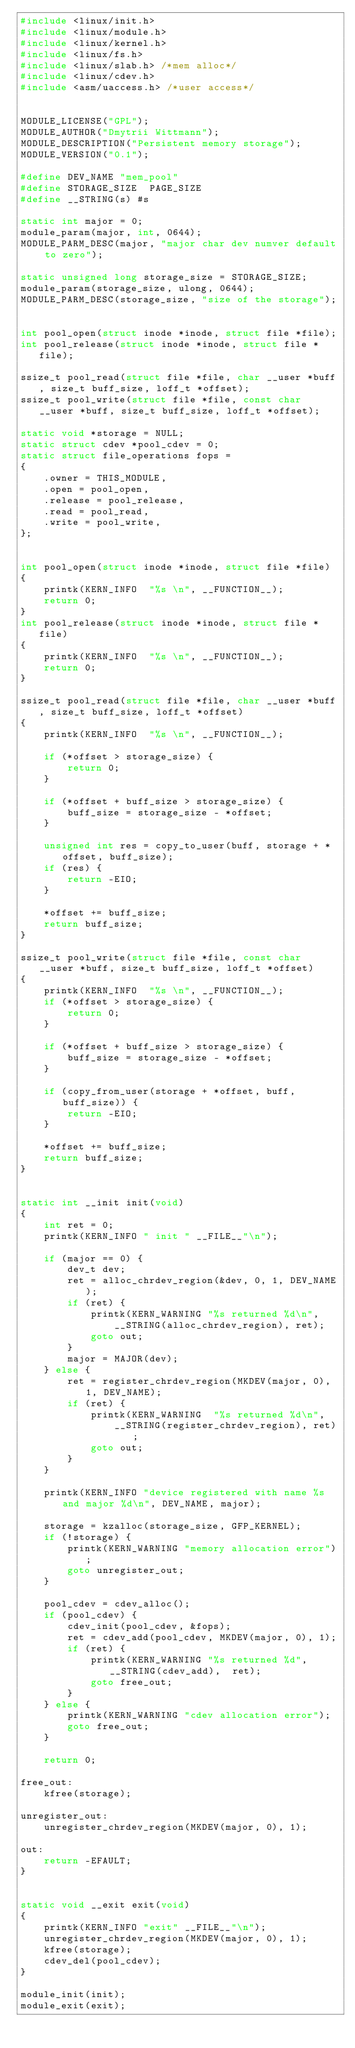<code> <loc_0><loc_0><loc_500><loc_500><_C_>#include <linux/init.h>
#include <linux/module.h>
#include <linux/kernel.h>
#include <linux/fs.h>
#include <linux/slab.h> /*mem alloc*/
#include <linux/cdev.h>
#include <asm/uaccess.h> /*user access*/ 

 
MODULE_LICENSE("GPL");
MODULE_AUTHOR("Dmytrii Wittmann");
MODULE_DESCRIPTION("Persistent memory storage");
MODULE_VERSION("0.1");

#define DEV_NAME "mem_pool"
#define STORAGE_SIZE  PAGE_SIZE
#define __STRING(s) #s

static int major = 0;
module_param(major, int, 0644);
MODULE_PARM_DESC(major, "major char dev numver default to zero");

static unsigned long storage_size = STORAGE_SIZE;
module_param(storage_size, ulong, 0644);
MODULE_PARM_DESC(storage_size, "size of the storage");


int pool_open(struct inode *inode, struct file *file);
int pool_release(struct inode *inode, struct file *file);

ssize_t pool_read(struct file *file, char __user *buff, size_t buff_size, loff_t *offset);
ssize_t pool_write(struct file *file, const char __user *buff, size_t buff_size, loff_t *offset);

static void *storage = NULL;
static struct cdev *pool_cdev = 0;
static struct file_operations fops = 
{
	.owner = THIS_MODULE,
	.open = pool_open,
	.release = pool_release,
	.read = pool_read,
	.write = pool_write,
};


int pool_open(struct inode *inode, struct file *file)
{
	printk(KERN_INFO  "%s \n", __FUNCTION__);
	return 0;
}
int pool_release(struct inode *inode, struct file *file)
{
	printk(KERN_INFO  "%s \n", __FUNCTION__);
	return 0;
}

ssize_t pool_read(struct file *file, char __user *buff, size_t buff_size, loff_t *offset)
{
	printk(KERN_INFO  "%s \n", __FUNCTION__);

	if (*offset > storage_size) {
		return 0;
	}

	if (*offset + buff_size > storage_size) {
		buff_size = storage_size - *offset;
	}

	unsigned int res = copy_to_user(buff, storage + *offset, buff_size);
	if (res) {
		return -EIO;
	}

	*offset += buff_size;
	return buff_size;
}

ssize_t pool_write(struct file *file, const char __user *buff, size_t buff_size, loff_t *offset)
{
	printk(KERN_INFO  "%s \n", __FUNCTION__);
	if (*offset > storage_size) {
		return 0;
	}

	if (*offset + buff_size > storage_size) {
		buff_size = storage_size - *offset;
	}

	if (copy_from_user(storage + *offset, buff, buff_size)) {
		return -EIO;
	}

	*offset += buff_size;
	return buff_size;
}


static int __init init(void) 
{
	int ret = 0;
	printk(KERN_INFO " init " __FILE__"\n");

	if (major == 0) {
		dev_t dev;
		ret = alloc_chrdev_region(&dev, 0, 1, DEV_NAME);
		if (ret) {
			printk(KERN_WARNING "%s returned %d\n",  
				__STRING(alloc_chrdev_region), ret);
			goto out;
		}
		major = MAJOR(dev);
	} else {
		ret = register_chrdev_region(MKDEV(major, 0), 1, DEV_NAME);
		if (ret) {
			printk(KERN_WARNING  "%s returned %d\n", 
				__STRING(register_chrdev_region), ret);
			goto out;
		}
	}

	printk(KERN_INFO "device registered with name %s and major %d\n", DEV_NAME, major);

	storage = kzalloc(storage_size, GFP_KERNEL);
	if (!storage) {
		printk(KERN_WARNING "memory allocation error");
		goto unregister_out;
	}

	pool_cdev = cdev_alloc();
	if (pool_cdev) {
		cdev_init(pool_cdev, &fops);
		ret = cdev_add(pool_cdev, MKDEV(major, 0), 1);
		if (ret) {
			printk(KERN_WARNING "%s returned %d", __STRING(cdev_add),  ret);
			goto free_out;
		}
	} else {
		printk(KERN_WARNING "cdev allocation error");
		goto free_out;
	}

	return 0;

free_out:
	kfree(storage);

unregister_out:
	unregister_chrdev_region(MKDEV(major, 0), 1);

out:
	return -EFAULT;
}


static void __exit exit(void)
{
	printk(KERN_INFO "exit" __FILE__"\n");
	unregister_chrdev_region(MKDEV(major, 0), 1);
	kfree(storage);
	cdev_del(pool_cdev);
}

module_init(init);
module_exit(exit);
</code> 